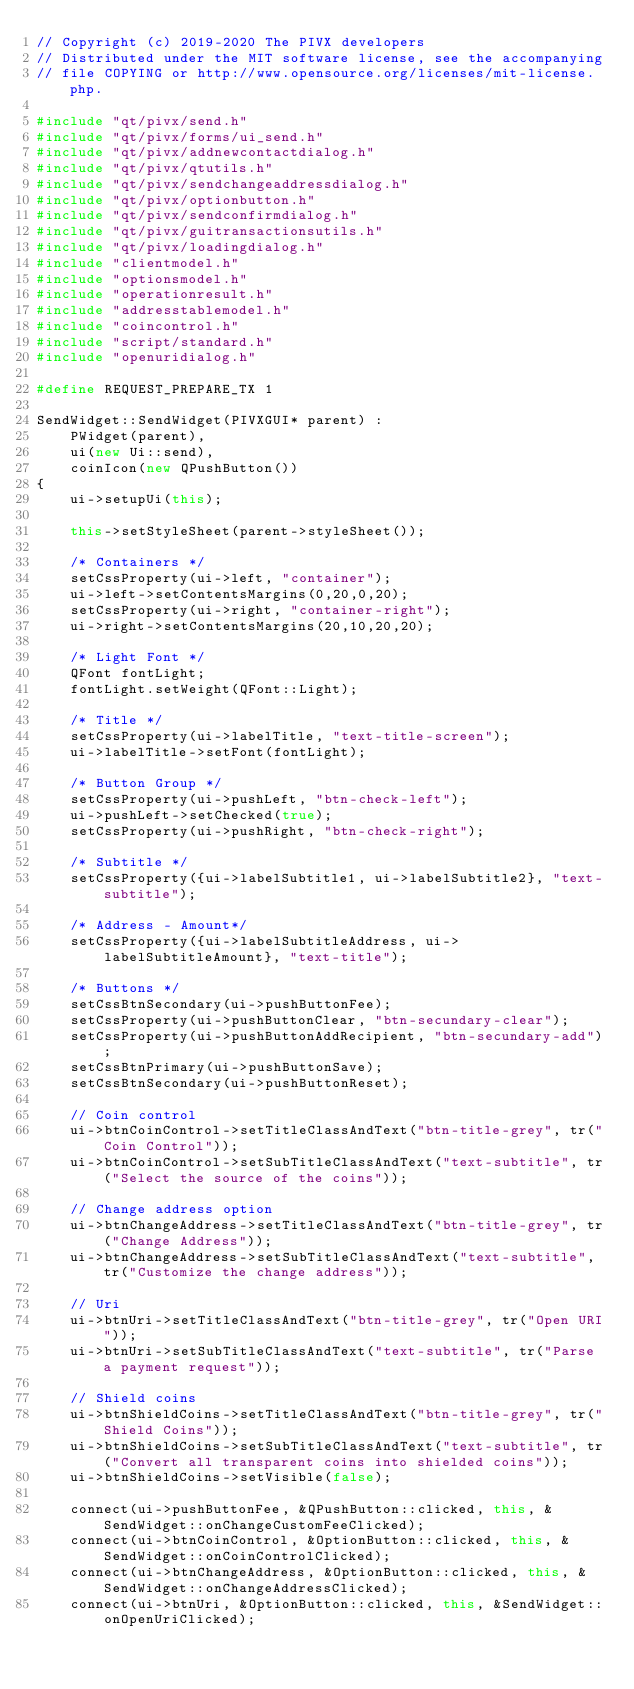<code> <loc_0><loc_0><loc_500><loc_500><_C++_>// Copyright (c) 2019-2020 The PIVX developers
// Distributed under the MIT software license, see the accompanying
// file COPYING or http://www.opensource.org/licenses/mit-license.php.

#include "qt/pivx/send.h"
#include "qt/pivx/forms/ui_send.h"
#include "qt/pivx/addnewcontactdialog.h"
#include "qt/pivx/qtutils.h"
#include "qt/pivx/sendchangeaddressdialog.h"
#include "qt/pivx/optionbutton.h"
#include "qt/pivx/sendconfirmdialog.h"
#include "qt/pivx/guitransactionsutils.h"
#include "qt/pivx/loadingdialog.h"
#include "clientmodel.h"
#include "optionsmodel.h"
#include "operationresult.h"
#include "addresstablemodel.h"
#include "coincontrol.h"
#include "script/standard.h"
#include "openuridialog.h"

#define REQUEST_PREPARE_TX 1

SendWidget::SendWidget(PIVXGUI* parent) :
    PWidget(parent),
    ui(new Ui::send),
    coinIcon(new QPushButton())
{
    ui->setupUi(this);

    this->setStyleSheet(parent->styleSheet());

    /* Containers */
    setCssProperty(ui->left, "container");
    ui->left->setContentsMargins(0,20,0,20);
    setCssProperty(ui->right, "container-right");
    ui->right->setContentsMargins(20,10,20,20);

    /* Light Font */
    QFont fontLight;
    fontLight.setWeight(QFont::Light);

    /* Title */
    setCssProperty(ui->labelTitle, "text-title-screen");
    ui->labelTitle->setFont(fontLight);

    /* Button Group */
    setCssProperty(ui->pushLeft, "btn-check-left");
    ui->pushLeft->setChecked(true);
    setCssProperty(ui->pushRight, "btn-check-right");

    /* Subtitle */
    setCssProperty({ui->labelSubtitle1, ui->labelSubtitle2}, "text-subtitle");

    /* Address - Amount*/
    setCssProperty({ui->labelSubtitleAddress, ui->labelSubtitleAmount}, "text-title");

    /* Buttons */
    setCssBtnSecondary(ui->pushButtonFee);
    setCssProperty(ui->pushButtonClear, "btn-secundary-clear");
    setCssProperty(ui->pushButtonAddRecipient, "btn-secundary-add");
    setCssBtnPrimary(ui->pushButtonSave);
    setCssBtnSecondary(ui->pushButtonReset);

    // Coin control
    ui->btnCoinControl->setTitleClassAndText("btn-title-grey", tr("Coin Control"));
    ui->btnCoinControl->setSubTitleClassAndText("text-subtitle", tr("Select the source of the coins"));

    // Change address option
    ui->btnChangeAddress->setTitleClassAndText("btn-title-grey", tr("Change Address"));
    ui->btnChangeAddress->setSubTitleClassAndText("text-subtitle", tr("Customize the change address"));

    // Uri
    ui->btnUri->setTitleClassAndText("btn-title-grey", tr("Open URI"));
    ui->btnUri->setSubTitleClassAndText("text-subtitle", tr("Parse a payment request"));

    // Shield coins
    ui->btnShieldCoins->setTitleClassAndText("btn-title-grey", tr("Shield Coins"));
    ui->btnShieldCoins->setSubTitleClassAndText("text-subtitle", tr("Convert all transparent coins into shielded coins"));
    ui->btnShieldCoins->setVisible(false);

    connect(ui->pushButtonFee, &QPushButton::clicked, this, &SendWidget::onChangeCustomFeeClicked);
    connect(ui->btnCoinControl, &OptionButton::clicked, this, &SendWidget::onCoinControlClicked);
    connect(ui->btnChangeAddress, &OptionButton::clicked, this, &SendWidget::onChangeAddressClicked);
    connect(ui->btnUri, &OptionButton::clicked, this, &SendWidget::onOpenUriClicked);</code> 